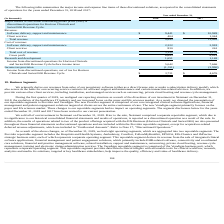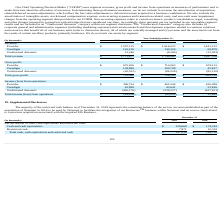According to Allscripts Healthcare Solutions's financial document, What is the total revenue in 2019? According to the financial document, $1,771,677 (in thousands). The relevant text states: "Total revenue $ 1,771,677 $ 1,749,962 $ 1,497,708..." Also, What is the total revenue in 2018? According to the financial document, $1,749,962 (in thousands). The relevant text states: "Total revenue $ 1,771,677 $ 1,749,962 $ 1,497,708..." Also, What is the total revenue in 2017? According to the financial document, $1,497,708 (in thousands). The relevant text states: "Total revenue $ 1,771,677 $ 1,749,962 $ 1,497,708..." Also, can you calculate: What is the change in Revenue from Provider between 2018 and 2017? Based on the calculation: 1,616,022-1,441,212, the result is 174810 (in thousands). This is based on the information: "Provider $ 1,597,115 $ 1,616,022 $ 1,441,212 Provider $ 1,597,115 $ 1,616,022 $ 1,441,212..." The key data points involved are: 1,441,212, 1,616,022. Also, can you calculate: What is the change in Revenue from Veradigm between 2018 and 2017? Based on the calculation: 140,326-69,879, the result is 70447 (in thousands). This is based on the information: "Veradigm 161,216 140,326 69,879 Veradigm 161,216 140,326 69,879..." The key data points involved are: 140,326, 69,879. Additionally, Which year has the highest total revenue? According to the financial document, 2019. The relevant text states: "(In thousands) 2019 2018 2017..." 